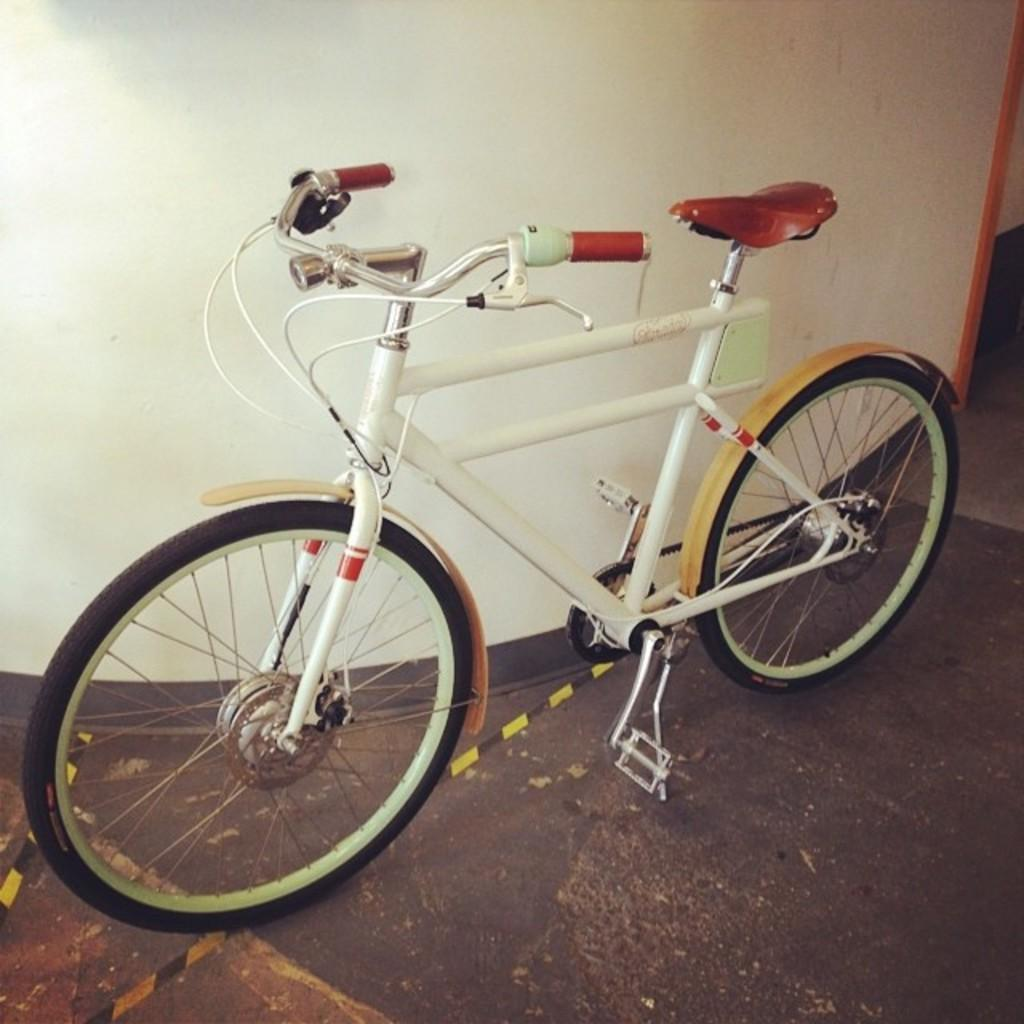What object is placed on the floor in the image? There is a bicycle on the floor in the image. What can be seen in the background of the image? There is a wall visible in the background of the image. How many grapes can be seen on the bicycle in the image? There are no grapes present on the bicycle or in the image. 